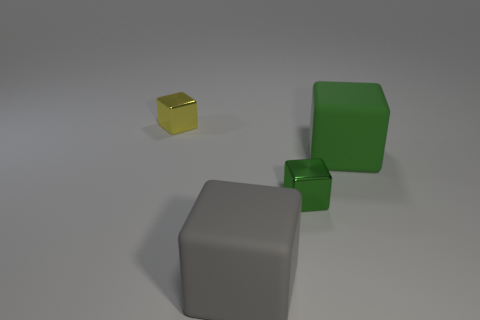Subtract all green metallic blocks. How many blocks are left? 3 Add 4 tiny metal cubes. How many objects exist? 8 Subtract all cyan cylinders. How many green cubes are left? 2 Subtract all green cubes. How many cubes are left? 2 Subtract 1 gray blocks. How many objects are left? 3 Subtract 1 cubes. How many cubes are left? 3 Subtract all brown blocks. Subtract all brown spheres. How many blocks are left? 4 Subtract all large green spheres. Subtract all cubes. How many objects are left? 0 Add 3 big rubber cubes. How many big rubber cubes are left? 5 Add 1 big green rubber balls. How many big green rubber balls exist? 1 